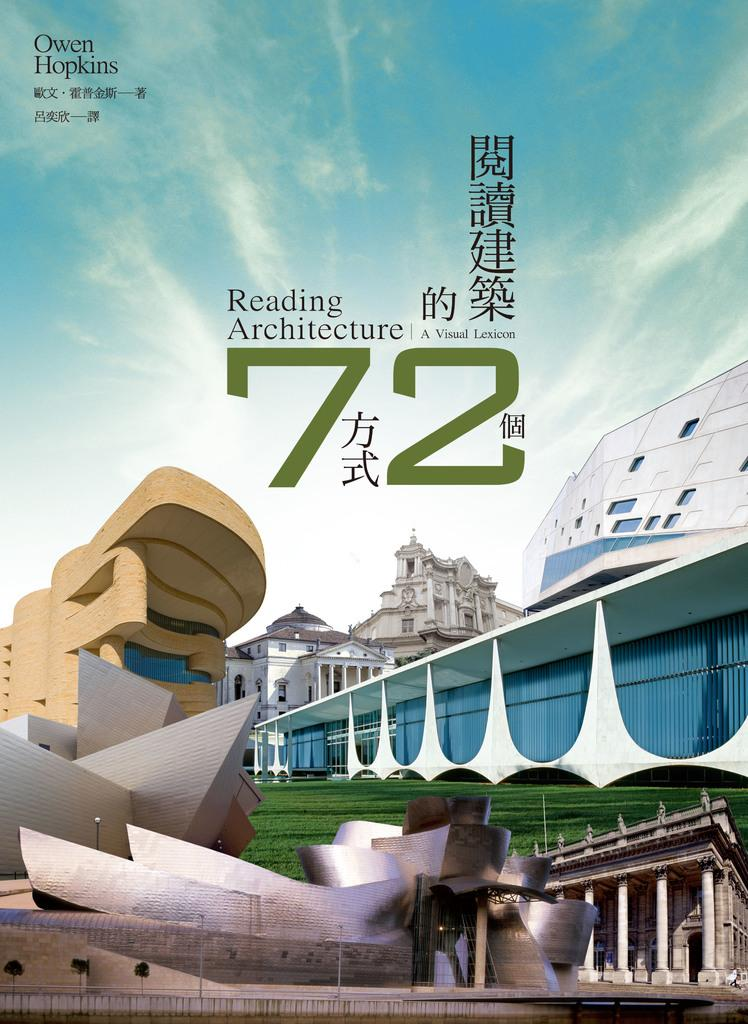What is the main subject of the magazine in the image? The magazine contains images of buildings with walls. What can be seen in the images of the buildings? Grass is present in the images of the buildings, and there is a pole visible in the magazine. What is visible in the background of the images in the magazine? The background of the images in the magazine includes the sky. Is there any text in the magazine? Yes, there is text visible in the magazine. How many bikes are parked next to the buildings in the images? There are no bikes present in the images; they only show buildings with walls, grass, a pole, and the sky in the background. What type of skirt is worn by the person in the image? There is no person wearing a skirt in the image; it only contains images of buildings with walls, grass, a pole, and the sky in the background. 